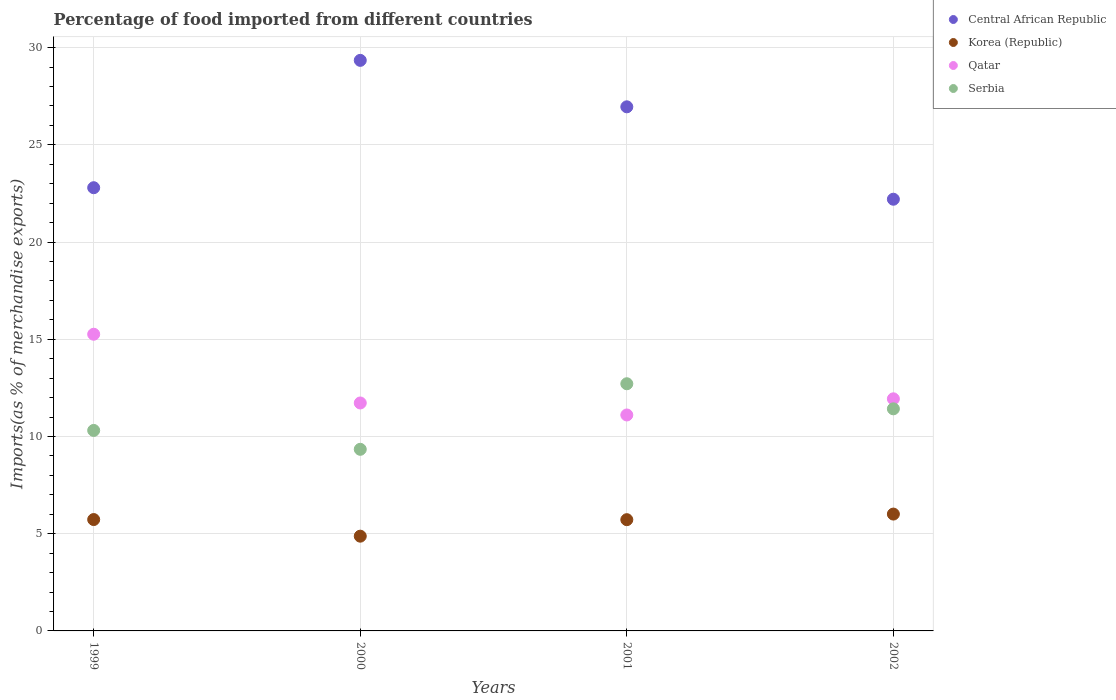What is the percentage of imports to different countries in Serbia in 2000?
Your answer should be very brief. 9.34. Across all years, what is the maximum percentage of imports to different countries in Serbia?
Give a very brief answer. 12.71. Across all years, what is the minimum percentage of imports to different countries in Qatar?
Your response must be concise. 11.11. What is the total percentage of imports to different countries in Korea (Republic) in the graph?
Ensure brevity in your answer.  22.33. What is the difference between the percentage of imports to different countries in Central African Republic in 2001 and that in 2002?
Make the answer very short. 4.75. What is the difference between the percentage of imports to different countries in Serbia in 2002 and the percentage of imports to different countries in Korea (Republic) in 2000?
Ensure brevity in your answer.  6.55. What is the average percentage of imports to different countries in Korea (Republic) per year?
Make the answer very short. 5.58. In the year 1999, what is the difference between the percentage of imports to different countries in Qatar and percentage of imports to different countries in Korea (Republic)?
Keep it short and to the point. 9.53. In how many years, is the percentage of imports to different countries in Korea (Republic) greater than 26 %?
Give a very brief answer. 0. What is the ratio of the percentage of imports to different countries in Serbia in 1999 to that in 2000?
Ensure brevity in your answer.  1.1. What is the difference between the highest and the second highest percentage of imports to different countries in Qatar?
Offer a terse response. 3.32. What is the difference between the highest and the lowest percentage of imports to different countries in Serbia?
Your response must be concise. 3.37. Is the percentage of imports to different countries in Korea (Republic) strictly greater than the percentage of imports to different countries in Serbia over the years?
Your answer should be compact. No. How many dotlines are there?
Keep it short and to the point. 4. How many years are there in the graph?
Your answer should be very brief. 4. How many legend labels are there?
Offer a terse response. 4. What is the title of the graph?
Your answer should be compact. Percentage of food imported from different countries. What is the label or title of the Y-axis?
Give a very brief answer. Imports(as % of merchandise exports). What is the Imports(as % of merchandise exports) in Central African Republic in 1999?
Provide a succinct answer. 22.79. What is the Imports(as % of merchandise exports) of Korea (Republic) in 1999?
Give a very brief answer. 5.73. What is the Imports(as % of merchandise exports) of Qatar in 1999?
Make the answer very short. 15.26. What is the Imports(as % of merchandise exports) in Serbia in 1999?
Offer a terse response. 10.31. What is the Imports(as % of merchandise exports) in Central African Republic in 2000?
Offer a very short reply. 29.34. What is the Imports(as % of merchandise exports) of Korea (Republic) in 2000?
Your answer should be compact. 4.87. What is the Imports(as % of merchandise exports) in Qatar in 2000?
Offer a terse response. 11.72. What is the Imports(as % of merchandise exports) in Serbia in 2000?
Provide a short and direct response. 9.34. What is the Imports(as % of merchandise exports) in Central African Republic in 2001?
Your answer should be compact. 26.95. What is the Imports(as % of merchandise exports) in Korea (Republic) in 2001?
Make the answer very short. 5.72. What is the Imports(as % of merchandise exports) in Qatar in 2001?
Provide a short and direct response. 11.11. What is the Imports(as % of merchandise exports) in Serbia in 2001?
Your answer should be compact. 12.71. What is the Imports(as % of merchandise exports) in Central African Republic in 2002?
Your answer should be very brief. 22.2. What is the Imports(as % of merchandise exports) in Korea (Republic) in 2002?
Give a very brief answer. 6.01. What is the Imports(as % of merchandise exports) in Qatar in 2002?
Offer a very short reply. 11.94. What is the Imports(as % of merchandise exports) of Serbia in 2002?
Keep it short and to the point. 11.42. Across all years, what is the maximum Imports(as % of merchandise exports) of Central African Republic?
Provide a succinct answer. 29.34. Across all years, what is the maximum Imports(as % of merchandise exports) in Korea (Republic)?
Your answer should be compact. 6.01. Across all years, what is the maximum Imports(as % of merchandise exports) of Qatar?
Provide a short and direct response. 15.26. Across all years, what is the maximum Imports(as % of merchandise exports) in Serbia?
Your answer should be very brief. 12.71. Across all years, what is the minimum Imports(as % of merchandise exports) of Central African Republic?
Provide a short and direct response. 22.2. Across all years, what is the minimum Imports(as % of merchandise exports) in Korea (Republic)?
Your response must be concise. 4.87. Across all years, what is the minimum Imports(as % of merchandise exports) in Qatar?
Offer a very short reply. 11.11. Across all years, what is the minimum Imports(as % of merchandise exports) in Serbia?
Your response must be concise. 9.34. What is the total Imports(as % of merchandise exports) of Central African Republic in the graph?
Ensure brevity in your answer.  101.29. What is the total Imports(as % of merchandise exports) of Korea (Republic) in the graph?
Your answer should be very brief. 22.33. What is the total Imports(as % of merchandise exports) of Qatar in the graph?
Make the answer very short. 50.02. What is the total Imports(as % of merchandise exports) of Serbia in the graph?
Provide a short and direct response. 43.79. What is the difference between the Imports(as % of merchandise exports) in Central African Republic in 1999 and that in 2000?
Your response must be concise. -6.55. What is the difference between the Imports(as % of merchandise exports) of Korea (Republic) in 1999 and that in 2000?
Your answer should be compact. 0.85. What is the difference between the Imports(as % of merchandise exports) in Qatar in 1999 and that in 2000?
Your answer should be very brief. 3.54. What is the difference between the Imports(as % of merchandise exports) of Serbia in 1999 and that in 2000?
Your answer should be very brief. 0.97. What is the difference between the Imports(as % of merchandise exports) of Central African Republic in 1999 and that in 2001?
Keep it short and to the point. -4.16. What is the difference between the Imports(as % of merchandise exports) in Korea (Republic) in 1999 and that in 2001?
Your answer should be compact. 0.01. What is the difference between the Imports(as % of merchandise exports) of Qatar in 1999 and that in 2001?
Your response must be concise. 4.15. What is the difference between the Imports(as % of merchandise exports) of Serbia in 1999 and that in 2001?
Offer a terse response. -2.4. What is the difference between the Imports(as % of merchandise exports) of Central African Republic in 1999 and that in 2002?
Ensure brevity in your answer.  0.59. What is the difference between the Imports(as % of merchandise exports) in Korea (Republic) in 1999 and that in 2002?
Your answer should be compact. -0.28. What is the difference between the Imports(as % of merchandise exports) of Qatar in 1999 and that in 2002?
Your response must be concise. 3.32. What is the difference between the Imports(as % of merchandise exports) of Serbia in 1999 and that in 2002?
Keep it short and to the point. -1.11. What is the difference between the Imports(as % of merchandise exports) in Central African Republic in 2000 and that in 2001?
Your answer should be very brief. 2.39. What is the difference between the Imports(as % of merchandise exports) of Korea (Republic) in 2000 and that in 2001?
Offer a terse response. -0.85. What is the difference between the Imports(as % of merchandise exports) of Qatar in 2000 and that in 2001?
Make the answer very short. 0.62. What is the difference between the Imports(as % of merchandise exports) in Serbia in 2000 and that in 2001?
Your answer should be very brief. -3.37. What is the difference between the Imports(as % of merchandise exports) in Central African Republic in 2000 and that in 2002?
Provide a succinct answer. 7.14. What is the difference between the Imports(as % of merchandise exports) of Korea (Republic) in 2000 and that in 2002?
Provide a succinct answer. -1.14. What is the difference between the Imports(as % of merchandise exports) in Qatar in 2000 and that in 2002?
Provide a short and direct response. -0.21. What is the difference between the Imports(as % of merchandise exports) in Serbia in 2000 and that in 2002?
Make the answer very short. -2.08. What is the difference between the Imports(as % of merchandise exports) of Central African Republic in 2001 and that in 2002?
Your answer should be very brief. 4.75. What is the difference between the Imports(as % of merchandise exports) in Korea (Republic) in 2001 and that in 2002?
Your response must be concise. -0.29. What is the difference between the Imports(as % of merchandise exports) of Qatar in 2001 and that in 2002?
Your response must be concise. -0.83. What is the difference between the Imports(as % of merchandise exports) of Serbia in 2001 and that in 2002?
Your response must be concise. 1.29. What is the difference between the Imports(as % of merchandise exports) in Central African Republic in 1999 and the Imports(as % of merchandise exports) in Korea (Republic) in 2000?
Make the answer very short. 17.92. What is the difference between the Imports(as % of merchandise exports) in Central African Republic in 1999 and the Imports(as % of merchandise exports) in Qatar in 2000?
Your response must be concise. 11.07. What is the difference between the Imports(as % of merchandise exports) in Central African Republic in 1999 and the Imports(as % of merchandise exports) in Serbia in 2000?
Provide a succinct answer. 13.45. What is the difference between the Imports(as % of merchandise exports) in Korea (Republic) in 1999 and the Imports(as % of merchandise exports) in Qatar in 2000?
Your response must be concise. -6. What is the difference between the Imports(as % of merchandise exports) in Korea (Republic) in 1999 and the Imports(as % of merchandise exports) in Serbia in 2000?
Your answer should be compact. -3.61. What is the difference between the Imports(as % of merchandise exports) of Qatar in 1999 and the Imports(as % of merchandise exports) of Serbia in 2000?
Make the answer very short. 5.92. What is the difference between the Imports(as % of merchandise exports) in Central African Republic in 1999 and the Imports(as % of merchandise exports) in Korea (Republic) in 2001?
Your answer should be very brief. 17.07. What is the difference between the Imports(as % of merchandise exports) in Central African Republic in 1999 and the Imports(as % of merchandise exports) in Qatar in 2001?
Offer a very short reply. 11.69. What is the difference between the Imports(as % of merchandise exports) of Central African Republic in 1999 and the Imports(as % of merchandise exports) of Serbia in 2001?
Offer a very short reply. 10.08. What is the difference between the Imports(as % of merchandise exports) in Korea (Republic) in 1999 and the Imports(as % of merchandise exports) in Qatar in 2001?
Provide a short and direct response. -5.38. What is the difference between the Imports(as % of merchandise exports) of Korea (Republic) in 1999 and the Imports(as % of merchandise exports) of Serbia in 2001?
Keep it short and to the point. -6.98. What is the difference between the Imports(as % of merchandise exports) of Qatar in 1999 and the Imports(as % of merchandise exports) of Serbia in 2001?
Offer a very short reply. 2.55. What is the difference between the Imports(as % of merchandise exports) in Central African Republic in 1999 and the Imports(as % of merchandise exports) in Korea (Republic) in 2002?
Give a very brief answer. 16.78. What is the difference between the Imports(as % of merchandise exports) in Central African Republic in 1999 and the Imports(as % of merchandise exports) in Qatar in 2002?
Your response must be concise. 10.86. What is the difference between the Imports(as % of merchandise exports) of Central African Republic in 1999 and the Imports(as % of merchandise exports) of Serbia in 2002?
Provide a short and direct response. 11.37. What is the difference between the Imports(as % of merchandise exports) in Korea (Republic) in 1999 and the Imports(as % of merchandise exports) in Qatar in 2002?
Make the answer very short. -6.21. What is the difference between the Imports(as % of merchandise exports) in Korea (Republic) in 1999 and the Imports(as % of merchandise exports) in Serbia in 2002?
Provide a short and direct response. -5.69. What is the difference between the Imports(as % of merchandise exports) of Qatar in 1999 and the Imports(as % of merchandise exports) of Serbia in 2002?
Provide a succinct answer. 3.84. What is the difference between the Imports(as % of merchandise exports) in Central African Republic in 2000 and the Imports(as % of merchandise exports) in Korea (Republic) in 2001?
Provide a short and direct response. 23.62. What is the difference between the Imports(as % of merchandise exports) in Central African Republic in 2000 and the Imports(as % of merchandise exports) in Qatar in 2001?
Make the answer very short. 18.24. What is the difference between the Imports(as % of merchandise exports) of Central African Republic in 2000 and the Imports(as % of merchandise exports) of Serbia in 2001?
Your answer should be very brief. 16.63. What is the difference between the Imports(as % of merchandise exports) of Korea (Republic) in 2000 and the Imports(as % of merchandise exports) of Qatar in 2001?
Your answer should be very brief. -6.23. What is the difference between the Imports(as % of merchandise exports) of Korea (Republic) in 2000 and the Imports(as % of merchandise exports) of Serbia in 2001?
Provide a succinct answer. -7.84. What is the difference between the Imports(as % of merchandise exports) of Qatar in 2000 and the Imports(as % of merchandise exports) of Serbia in 2001?
Ensure brevity in your answer.  -0.99. What is the difference between the Imports(as % of merchandise exports) of Central African Republic in 2000 and the Imports(as % of merchandise exports) of Korea (Republic) in 2002?
Provide a short and direct response. 23.33. What is the difference between the Imports(as % of merchandise exports) in Central African Republic in 2000 and the Imports(as % of merchandise exports) in Qatar in 2002?
Your answer should be very brief. 17.41. What is the difference between the Imports(as % of merchandise exports) of Central African Republic in 2000 and the Imports(as % of merchandise exports) of Serbia in 2002?
Offer a very short reply. 17.92. What is the difference between the Imports(as % of merchandise exports) of Korea (Republic) in 2000 and the Imports(as % of merchandise exports) of Qatar in 2002?
Provide a succinct answer. -7.06. What is the difference between the Imports(as % of merchandise exports) in Korea (Republic) in 2000 and the Imports(as % of merchandise exports) in Serbia in 2002?
Your response must be concise. -6.55. What is the difference between the Imports(as % of merchandise exports) in Qatar in 2000 and the Imports(as % of merchandise exports) in Serbia in 2002?
Provide a short and direct response. 0.3. What is the difference between the Imports(as % of merchandise exports) of Central African Republic in 2001 and the Imports(as % of merchandise exports) of Korea (Republic) in 2002?
Offer a very short reply. 20.95. What is the difference between the Imports(as % of merchandise exports) in Central African Republic in 2001 and the Imports(as % of merchandise exports) in Qatar in 2002?
Ensure brevity in your answer.  15.02. What is the difference between the Imports(as % of merchandise exports) in Central African Republic in 2001 and the Imports(as % of merchandise exports) in Serbia in 2002?
Provide a succinct answer. 15.53. What is the difference between the Imports(as % of merchandise exports) in Korea (Republic) in 2001 and the Imports(as % of merchandise exports) in Qatar in 2002?
Your answer should be compact. -6.22. What is the difference between the Imports(as % of merchandise exports) of Korea (Republic) in 2001 and the Imports(as % of merchandise exports) of Serbia in 2002?
Provide a succinct answer. -5.7. What is the difference between the Imports(as % of merchandise exports) in Qatar in 2001 and the Imports(as % of merchandise exports) in Serbia in 2002?
Make the answer very short. -0.32. What is the average Imports(as % of merchandise exports) of Central African Republic per year?
Keep it short and to the point. 25.32. What is the average Imports(as % of merchandise exports) in Korea (Republic) per year?
Your response must be concise. 5.58. What is the average Imports(as % of merchandise exports) of Qatar per year?
Provide a short and direct response. 12.51. What is the average Imports(as % of merchandise exports) of Serbia per year?
Keep it short and to the point. 10.95. In the year 1999, what is the difference between the Imports(as % of merchandise exports) of Central African Republic and Imports(as % of merchandise exports) of Korea (Republic)?
Keep it short and to the point. 17.07. In the year 1999, what is the difference between the Imports(as % of merchandise exports) in Central African Republic and Imports(as % of merchandise exports) in Qatar?
Give a very brief answer. 7.54. In the year 1999, what is the difference between the Imports(as % of merchandise exports) of Central African Republic and Imports(as % of merchandise exports) of Serbia?
Make the answer very short. 12.48. In the year 1999, what is the difference between the Imports(as % of merchandise exports) in Korea (Republic) and Imports(as % of merchandise exports) in Qatar?
Provide a succinct answer. -9.53. In the year 1999, what is the difference between the Imports(as % of merchandise exports) of Korea (Republic) and Imports(as % of merchandise exports) of Serbia?
Your answer should be very brief. -4.58. In the year 1999, what is the difference between the Imports(as % of merchandise exports) in Qatar and Imports(as % of merchandise exports) in Serbia?
Provide a succinct answer. 4.95. In the year 2000, what is the difference between the Imports(as % of merchandise exports) of Central African Republic and Imports(as % of merchandise exports) of Korea (Republic)?
Your response must be concise. 24.47. In the year 2000, what is the difference between the Imports(as % of merchandise exports) of Central African Republic and Imports(as % of merchandise exports) of Qatar?
Your response must be concise. 17.62. In the year 2000, what is the difference between the Imports(as % of merchandise exports) of Central African Republic and Imports(as % of merchandise exports) of Serbia?
Ensure brevity in your answer.  20. In the year 2000, what is the difference between the Imports(as % of merchandise exports) in Korea (Republic) and Imports(as % of merchandise exports) in Qatar?
Give a very brief answer. -6.85. In the year 2000, what is the difference between the Imports(as % of merchandise exports) in Korea (Republic) and Imports(as % of merchandise exports) in Serbia?
Provide a short and direct response. -4.47. In the year 2000, what is the difference between the Imports(as % of merchandise exports) of Qatar and Imports(as % of merchandise exports) of Serbia?
Your answer should be compact. 2.38. In the year 2001, what is the difference between the Imports(as % of merchandise exports) of Central African Republic and Imports(as % of merchandise exports) of Korea (Republic)?
Offer a terse response. 21.23. In the year 2001, what is the difference between the Imports(as % of merchandise exports) of Central African Republic and Imports(as % of merchandise exports) of Qatar?
Give a very brief answer. 15.85. In the year 2001, what is the difference between the Imports(as % of merchandise exports) in Central African Republic and Imports(as % of merchandise exports) in Serbia?
Offer a terse response. 14.24. In the year 2001, what is the difference between the Imports(as % of merchandise exports) in Korea (Republic) and Imports(as % of merchandise exports) in Qatar?
Provide a short and direct response. -5.38. In the year 2001, what is the difference between the Imports(as % of merchandise exports) in Korea (Republic) and Imports(as % of merchandise exports) in Serbia?
Keep it short and to the point. -6.99. In the year 2001, what is the difference between the Imports(as % of merchandise exports) of Qatar and Imports(as % of merchandise exports) of Serbia?
Give a very brief answer. -1.61. In the year 2002, what is the difference between the Imports(as % of merchandise exports) of Central African Republic and Imports(as % of merchandise exports) of Korea (Republic)?
Your response must be concise. 16.19. In the year 2002, what is the difference between the Imports(as % of merchandise exports) in Central African Republic and Imports(as % of merchandise exports) in Qatar?
Ensure brevity in your answer.  10.26. In the year 2002, what is the difference between the Imports(as % of merchandise exports) of Central African Republic and Imports(as % of merchandise exports) of Serbia?
Keep it short and to the point. 10.78. In the year 2002, what is the difference between the Imports(as % of merchandise exports) of Korea (Republic) and Imports(as % of merchandise exports) of Qatar?
Provide a short and direct response. -5.93. In the year 2002, what is the difference between the Imports(as % of merchandise exports) of Korea (Republic) and Imports(as % of merchandise exports) of Serbia?
Make the answer very short. -5.41. In the year 2002, what is the difference between the Imports(as % of merchandise exports) of Qatar and Imports(as % of merchandise exports) of Serbia?
Your response must be concise. 0.51. What is the ratio of the Imports(as % of merchandise exports) in Central African Republic in 1999 to that in 2000?
Make the answer very short. 0.78. What is the ratio of the Imports(as % of merchandise exports) in Korea (Republic) in 1999 to that in 2000?
Ensure brevity in your answer.  1.18. What is the ratio of the Imports(as % of merchandise exports) of Qatar in 1999 to that in 2000?
Provide a short and direct response. 1.3. What is the ratio of the Imports(as % of merchandise exports) of Serbia in 1999 to that in 2000?
Ensure brevity in your answer.  1.1. What is the ratio of the Imports(as % of merchandise exports) in Central African Republic in 1999 to that in 2001?
Make the answer very short. 0.85. What is the ratio of the Imports(as % of merchandise exports) in Korea (Republic) in 1999 to that in 2001?
Keep it short and to the point. 1. What is the ratio of the Imports(as % of merchandise exports) in Qatar in 1999 to that in 2001?
Provide a short and direct response. 1.37. What is the ratio of the Imports(as % of merchandise exports) of Serbia in 1999 to that in 2001?
Offer a terse response. 0.81. What is the ratio of the Imports(as % of merchandise exports) of Central African Republic in 1999 to that in 2002?
Give a very brief answer. 1.03. What is the ratio of the Imports(as % of merchandise exports) in Korea (Republic) in 1999 to that in 2002?
Offer a terse response. 0.95. What is the ratio of the Imports(as % of merchandise exports) of Qatar in 1999 to that in 2002?
Offer a very short reply. 1.28. What is the ratio of the Imports(as % of merchandise exports) in Serbia in 1999 to that in 2002?
Provide a succinct answer. 0.9. What is the ratio of the Imports(as % of merchandise exports) in Central African Republic in 2000 to that in 2001?
Keep it short and to the point. 1.09. What is the ratio of the Imports(as % of merchandise exports) of Korea (Republic) in 2000 to that in 2001?
Give a very brief answer. 0.85. What is the ratio of the Imports(as % of merchandise exports) in Qatar in 2000 to that in 2001?
Your answer should be compact. 1.06. What is the ratio of the Imports(as % of merchandise exports) of Serbia in 2000 to that in 2001?
Your answer should be very brief. 0.73. What is the ratio of the Imports(as % of merchandise exports) in Central African Republic in 2000 to that in 2002?
Offer a very short reply. 1.32. What is the ratio of the Imports(as % of merchandise exports) of Korea (Republic) in 2000 to that in 2002?
Offer a terse response. 0.81. What is the ratio of the Imports(as % of merchandise exports) in Qatar in 2000 to that in 2002?
Ensure brevity in your answer.  0.98. What is the ratio of the Imports(as % of merchandise exports) of Serbia in 2000 to that in 2002?
Your response must be concise. 0.82. What is the ratio of the Imports(as % of merchandise exports) of Central African Republic in 2001 to that in 2002?
Make the answer very short. 1.21. What is the ratio of the Imports(as % of merchandise exports) of Korea (Republic) in 2001 to that in 2002?
Provide a succinct answer. 0.95. What is the ratio of the Imports(as % of merchandise exports) of Qatar in 2001 to that in 2002?
Offer a very short reply. 0.93. What is the ratio of the Imports(as % of merchandise exports) of Serbia in 2001 to that in 2002?
Your answer should be compact. 1.11. What is the difference between the highest and the second highest Imports(as % of merchandise exports) of Central African Republic?
Provide a succinct answer. 2.39. What is the difference between the highest and the second highest Imports(as % of merchandise exports) in Korea (Republic)?
Make the answer very short. 0.28. What is the difference between the highest and the second highest Imports(as % of merchandise exports) of Qatar?
Keep it short and to the point. 3.32. What is the difference between the highest and the second highest Imports(as % of merchandise exports) in Serbia?
Offer a very short reply. 1.29. What is the difference between the highest and the lowest Imports(as % of merchandise exports) in Central African Republic?
Offer a terse response. 7.14. What is the difference between the highest and the lowest Imports(as % of merchandise exports) in Korea (Republic)?
Ensure brevity in your answer.  1.14. What is the difference between the highest and the lowest Imports(as % of merchandise exports) of Qatar?
Your response must be concise. 4.15. What is the difference between the highest and the lowest Imports(as % of merchandise exports) of Serbia?
Provide a succinct answer. 3.37. 